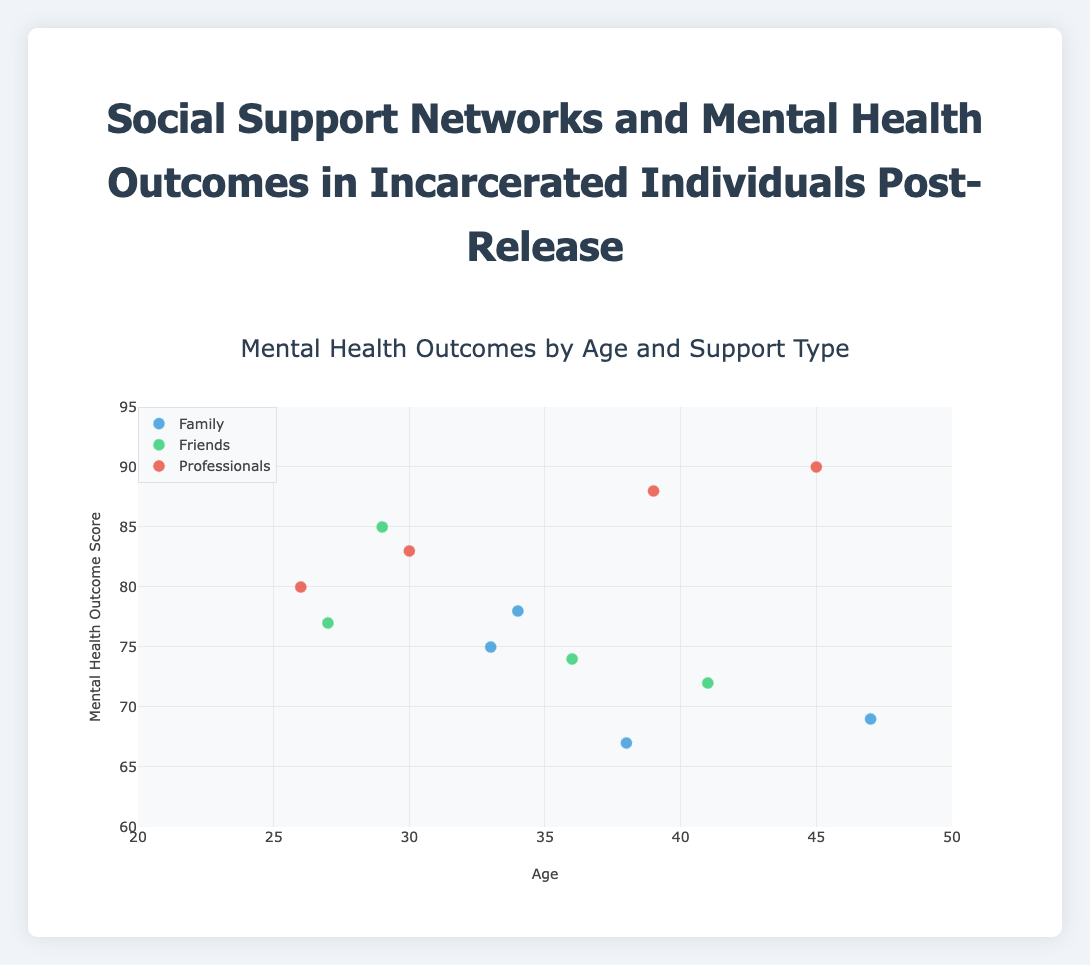What is the title of the plot? The title is displayed at the top of the plot and reads "Mental Health Outcomes by Age and Support Type".
Answer: Mental Health Outcomes by Age and Support Type How many support types are represented in the plot? The plot groups data points by support types indicated by different colors and noted in the legend. There are three groups: Family, Friends, and Professionals.
Answer: 3 Which individual has the highest mental health outcome score and what type of support do they have? To find the highest score, we review the y-axis values. The highest score is 90, belonging to Lisa Johnson who received professional support.
Answer: Lisa Johnson, Professionals What is the mental health outcome score for the oldest individual in the plot? The oldest individual shown is 47 years old (James Lee). To find his mental health outcome, check the corresponding y-axis value, which is 69.
Answer: 69 Which group shows the widest range of mental health outcome scores? To identify the group with the widest range, compare the highest and lowest scores in each support type. Family ranges from 67 to 78, Friends from 72 to 85, and Professionals from 80 to 90. The Friends group has the widest range.
Answer: Friends What is the average mental health outcome score for individuals who received support from friends? Add the mental health scores for individuals in the Friends group: 85, 72, 77, and 74. The sum is 308. Divide by the number of individuals (308/4).
Answer: 77 How do the mental health outcome scores for individuals supported by professionals compare to those supported by family? Compare the mental health scores of individuals in the Professionals group (90, 80, 88, 83) against those in the Family group (78, 67, 75, 69). On average, professional support results in higher scores.
Answer: Higher What is the difference in mental health outcome score between the youngest and oldest individuals? The youngest individual is Noah Wilson (26 years old) with a score of 80, and the oldest is James Lee (47 years old) with a score of 69. The difference is 80 - 69.
Answer: 11 Which individual received professional support and has the lowest mental health outcome score among their group? Among those with professional support, the lowest score is 80, which is received by Noah Wilson.
Answer: Noah Wilson 